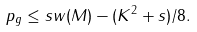<formula> <loc_0><loc_0><loc_500><loc_500>p _ { g } \leq { s w } ( M ) - ( K ^ { 2 } + s ) / 8 .</formula> 